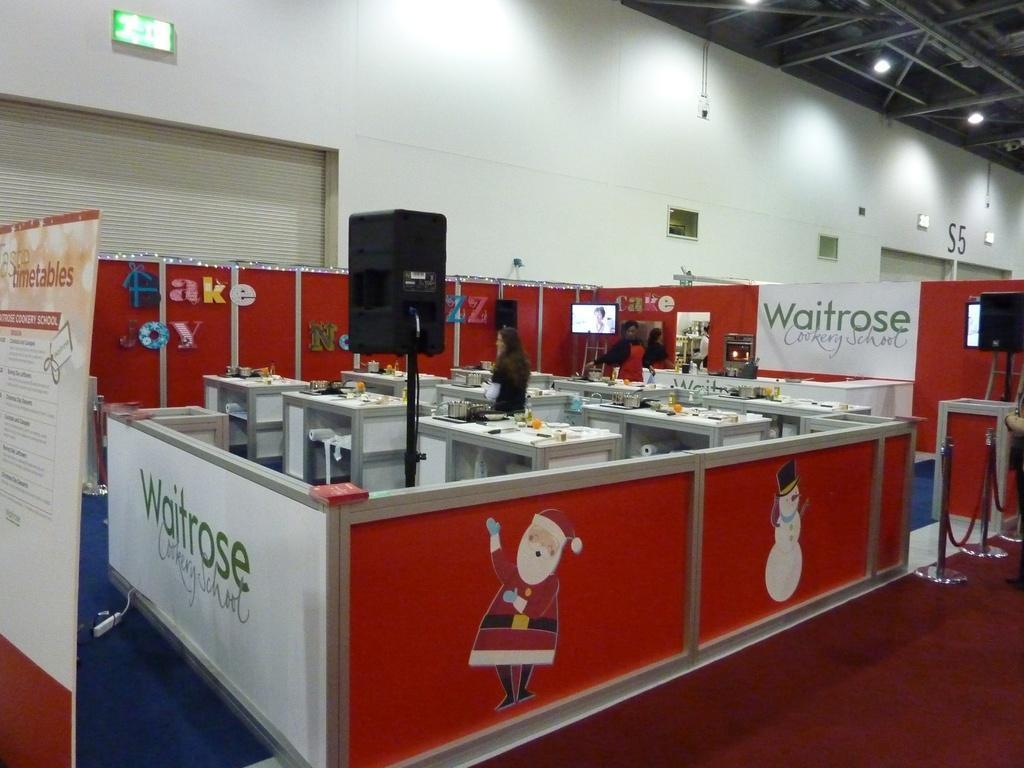Describe this image in one or two sentences. This picture looks like a store and I can see an advertisement board and a banner with some text and couple of women standing and I can see a television and few tables and I can see few lights on the ceiling and a speaker on the stand and I can see few cartoon images. 